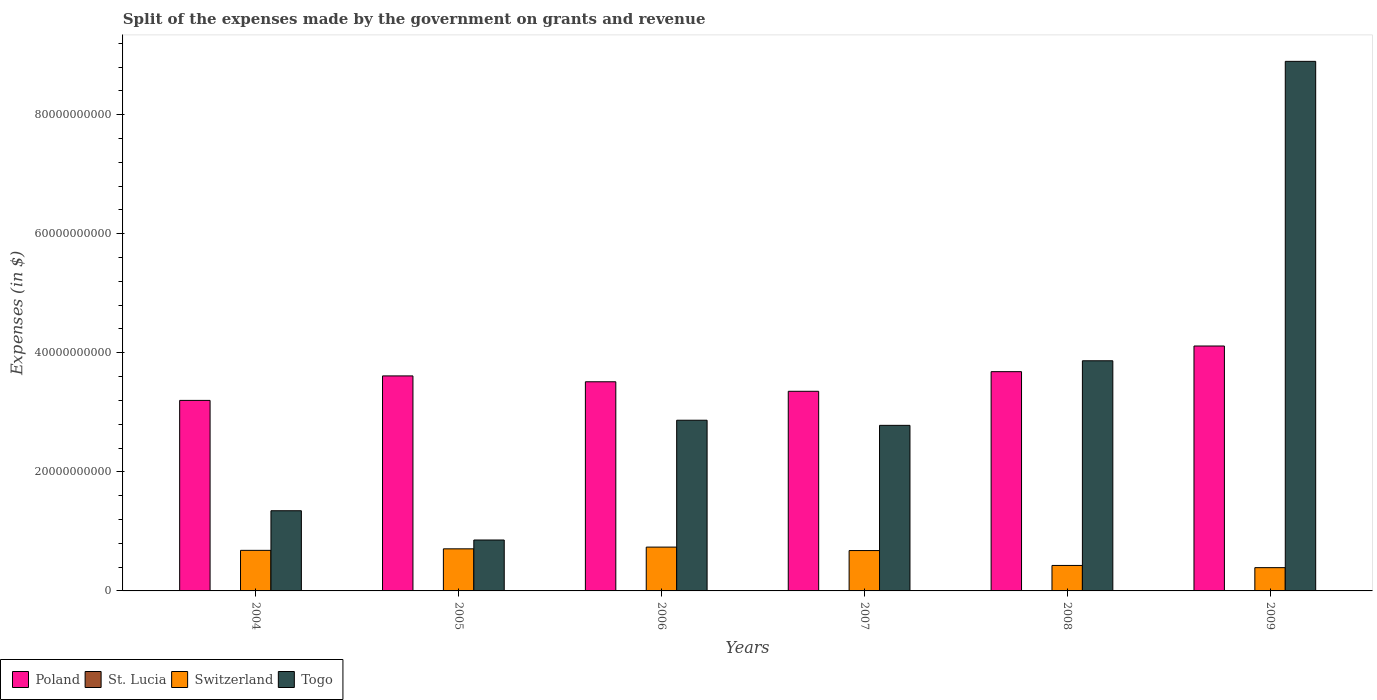How many different coloured bars are there?
Provide a short and direct response. 4. How many groups of bars are there?
Make the answer very short. 6. Are the number of bars on each tick of the X-axis equal?
Provide a short and direct response. Yes. What is the label of the 6th group of bars from the left?
Your answer should be very brief. 2009. In how many cases, is the number of bars for a given year not equal to the number of legend labels?
Give a very brief answer. 0. What is the expenses made by the government on grants and revenue in Switzerland in 2008?
Keep it short and to the point. 4.28e+09. Across all years, what is the maximum expenses made by the government on grants and revenue in St. Lucia?
Give a very brief answer. 2.59e+07. Across all years, what is the minimum expenses made by the government on grants and revenue in Switzerland?
Give a very brief answer. 3.91e+09. In which year was the expenses made by the government on grants and revenue in Switzerland minimum?
Provide a short and direct response. 2009. What is the total expenses made by the government on grants and revenue in Switzerland in the graph?
Provide a succinct answer. 3.62e+1. What is the difference between the expenses made by the government on grants and revenue in St. Lucia in 2005 and that in 2008?
Make the answer very short. -1.65e+07. What is the difference between the expenses made by the government on grants and revenue in Togo in 2007 and the expenses made by the government on grants and revenue in St. Lucia in 2008?
Provide a short and direct response. 2.78e+1. What is the average expenses made by the government on grants and revenue in Switzerland per year?
Provide a short and direct response. 6.04e+09. In the year 2009, what is the difference between the expenses made by the government on grants and revenue in St. Lucia and expenses made by the government on grants and revenue in Poland?
Provide a succinct answer. -4.11e+1. In how many years, is the expenses made by the government on grants and revenue in Switzerland greater than 32000000000 $?
Make the answer very short. 0. What is the ratio of the expenses made by the government on grants and revenue in St. Lucia in 2006 to that in 2009?
Make the answer very short. 0.13. What is the difference between the highest and the second highest expenses made by the government on grants and revenue in Togo?
Ensure brevity in your answer.  5.03e+1. What is the difference between the highest and the lowest expenses made by the government on grants and revenue in Poland?
Your response must be concise. 9.14e+09. Is it the case that in every year, the sum of the expenses made by the government on grants and revenue in Switzerland and expenses made by the government on grants and revenue in Poland is greater than the sum of expenses made by the government on grants and revenue in St. Lucia and expenses made by the government on grants and revenue in Togo?
Provide a short and direct response. No. What does the 2nd bar from the right in 2004 represents?
Your answer should be very brief. Switzerland. Is it the case that in every year, the sum of the expenses made by the government on grants and revenue in Poland and expenses made by the government on grants and revenue in St. Lucia is greater than the expenses made by the government on grants and revenue in Togo?
Offer a terse response. No. How many bars are there?
Keep it short and to the point. 24. Are all the bars in the graph horizontal?
Make the answer very short. No. How many years are there in the graph?
Make the answer very short. 6. Are the values on the major ticks of Y-axis written in scientific E-notation?
Give a very brief answer. No. Where does the legend appear in the graph?
Your answer should be compact. Bottom left. How many legend labels are there?
Offer a very short reply. 4. What is the title of the graph?
Offer a very short reply. Split of the expenses made by the government on grants and revenue. Does "Zimbabwe" appear as one of the legend labels in the graph?
Give a very brief answer. No. What is the label or title of the Y-axis?
Keep it short and to the point. Expenses (in $). What is the Expenses (in $) in Poland in 2004?
Provide a short and direct response. 3.20e+1. What is the Expenses (in $) in Switzerland in 2004?
Provide a succinct answer. 6.81e+09. What is the Expenses (in $) of Togo in 2004?
Give a very brief answer. 1.35e+1. What is the Expenses (in $) of Poland in 2005?
Your response must be concise. 3.61e+1. What is the Expenses (in $) in St. Lucia in 2005?
Give a very brief answer. 4.20e+06. What is the Expenses (in $) of Switzerland in 2005?
Offer a terse response. 7.07e+09. What is the Expenses (in $) of Togo in 2005?
Keep it short and to the point. 8.55e+09. What is the Expenses (in $) of Poland in 2006?
Your answer should be very brief. 3.51e+1. What is the Expenses (in $) in St. Lucia in 2006?
Give a very brief answer. 3.30e+06. What is the Expenses (in $) of Switzerland in 2006?
Give a very brief answer. 7.36e+09. What is the Expenses (in $) of Togo in 2006?
Offer a terse response. 2.87e+1. What is the Expenses (in $) of Poland in 2007?
Make the answer very short. 3.35e+1. What is the Expenses (in $) in St. Lucia in 2007?
Offer a very short reply. 9.30e+06. What is the Expenses (in $) of Switzerland in 2007?
Provide a succinct answer. 6.78e+09. What is the Expenses (in $) of Togo in 2007?
Keep it short and to the point. 2.78e+1. What is the Expenses (in $) of Poland in 2008?
Offer a very short reply. 3.68e+1. What is the Expenses (in $) of St. Lucia in 2008?
Make the answer very short. 2.07e+07. What is the Expenses (in $) of Switzerland in 2008?
Your answer should be compact. 4.28e+09. What is the Expenses (in $) in Togo in 2008?
Your answer should be compact. 3.87e+1. What is the Expenses (in $) of Poland in 2009?
Your response must be concise. 4.11e+1. What is the Expenses (in $) of St. Lucia in 2009?
Provide a succinct answer. 2.59e+07. What is the Expenses (in $) of Switzerland in 2009?
Make the answer very short. 3.91e+09. What is the Expenses (in $) of Togo in 2009?
Your answer should be very brief. 8.90e+1. Across all years, what is the maximum Expenses (in $) in Poland?
Provide a succinct answer. 4.11e+1. Across all years, what is the maximum Expenses (in $) in St. Lucia?
Ensure brevity in your answer.  2.59e+07. Across all years, what is the maximum Expenses (in $) in Switzerland?
Provide a short and direct response. 7.36e+09. Across all years, what is the maximum Expenses (in $) of Togo?
Give a very brief answer. 8.90e+1. Across all years, what is the minimum Expenses (in $) in Poland?
Keep it short and to the point. 3.20e+1. Across all years, what is the minimum Expenses (in $) of St. Lucia?
Make the answer very short. 3.30e+06. Across all years, what is the minimum Expenses (in $) of Switzerland?
Provide a short and direct response. 3.91e+09. Across all years, what is the minimum Expenses (in $) of Togo?
Ensure brevity in your answer.  8.55e+09. What is the total Expenses (in $) of Poland in the graph?
Your answer should be very brief. 2.15e+11. What is the total Expenses (in $) of St. Lucia in the graph?
Your answer should be very brief. 6.94e+07. What is the total Expenses (in $) in Switzerland in the graph?
Give a very brief answer. 3.62e+1. What is the total Expenses (in $) of Togo in the graph?
Provide a succinct answer. 2.06e+11. What is the difference between the Expenses (in $) in Poland in 2004 and that in 2005?
Provide a short and direct response. -4.12e+09. What is the difference between the Expenses (in $) in St. Lucia in 2004 and that in 2005?
Provide a succinct answer. 1.80e+06. What is the difference between the Expenses (in $) in Switzerland in 2004 and that in 2005?
Provide a short and direct response. -2.56e+08. What is the difference between the Expenses (in $) of Togo in 2004 and that in 2005?
Make the answer very short. 4.92e+09. What is the difference between the Expenses (in $) in Poland in 2004 and that in 2006?
Provide a succinct answer. -3.13e+09. What is the difference between the Expenses (in $) in St. Lucia in 2004 and that in 2006?
Ensure brevity in your answer.  2.70e+06. What is the difference between the Expenses (in $) in Switzerland in 2004 and that in 2006?
Your answer should be compact. -5.47e+08. What is the difference between the Expenses (in $) in Togo in 2004 and that in 2006?
Make the answer very short. -1.52e+1. What is the difference between the Expenses (in $) in Poland in 2004 and that in 2007?
Your answer should be very brief. -1.53e+09. What is the difference between the Expenses (in $) in St. Lucia in 2004 and that in 2007?
Make the answer very short. -3.30e+06. What is the difference between the Expenses (in $) of Switzerland in 2004 and that in 2007?
Your answer should be very brief. 3.30e+07. What is the difference between the Expenses (in $) in Togo in 2004 and that in 2007?
Your answer should be very brief. -1.43e+1. What is the difference between the Expenses (in $) in Poland in 2004 and that in 2008?
Provide a succinct answer. -4.83e+09. What is the difference between the Expenses (in $) in St. Lucia in 2004 and that in 2008?
Ensure brevity in your answer.  -1.47e+07. What is the difference between the Expenses (in $) of Switzerland in 2004 and that in 2008?
Keep it short and to the point. 2.54e+09. What is the difference between the Expenses (in $) of Togo in 2004 and that in 2008?
Make the answer very short. -2.52e+1. What is the difference between the Expenses (in $) of Poland in 2004 and that in 2009?
Ensure brevity in your answer.  -9.14e+09. What is the difference between the Expenses (in $) of St. Lucia in 2004 and that in 2009?
Your answer should be very brief. -1.99e+07. What is the difference between the Expenses (in $) of Switzerland in 2004 and that in 2009?
Provide a succinct answer. 2.90e+09. What is the difference between the Expenses (in $) in Togo in 2004 and that in 2009?
Offer a terse response. -7.55e+1. What is the difference between the Expenses (in $) of Poland in 2005 and that in 2006?
Offer a very short reply. 9.86e+08. What is the difference between the Expenses (in $) in Switzerland in 2005 and that in 2006?
Provide a succinct answer. -2.92e+08. What is the difference between the Expenses (in $) of Togo in 2005 and that in 2006?
Provide a short and direct response. -2.01e+1. What is the difference between the Expenses (in $) in Poland in 2005 and that in 2007?
Keep it short and to the point. 2.58e+09. What is the difference between the Expenses (in $) in St. Lucia in 2005 and that in 2007?
Your answer should be compact. -5.10e+06. What is the difference between the Expenses (in $) in Switzerland in 2005 and that in 2007?
Keep it short and to the point. 2.89e+08. What is the difference between the Expenses (in $) in Togo in 2005 and that in 2007?
Give a very brief answer. -1.93e+1. What is the difference between the Expenses (in $) in Poland in 2005 and that in 2008?
Give a very brief answer. -7.14e+08. What is the difference between the Expenses (in $) of St. Lucia in 2005 and that in 2008?
Give a very brief answer. -1.65e+07. What is the difference between the Expenses (in $) of Switzerland in 2005 and that in 2008?
Your answer should be very brief. 2.79e+09. What is the difference between the Expenses (in $) in Togo in 2005 and that in 2008?
Provide a succinct answer. -3.01e+1. What is the difference between the Expenses (in $) in Poland in 2005 and that in 2009?
Give a very brief answer. -5.02e+09. What is the difference between the Expenses (in $) of St. Lucia in 2005 and that in 2009?
Provide a succinct answer. -2.17e+07. What is the difference between the Expenses (in $) in Switzerland in 2005 and that in 2009?
Ensure brevity in your answer.  3.16e+09. What is the difference between the Expenses (in $) of Togo in 2005 and that in 2009?
Ensure brevity in your answer.  -8.04e+1. What is the difference between the Expenses (in $) of Poland in 2006 and that in 2007?
Your answer should be very brief. 1.60e+09. What is the difference between the Expenses (in $) in St. Lucia in 2006 and that in 2007?
Offer a very short reply. -6.00e+06. What is the difference between the Expenses (in $) in Switzerland in 2006 and that in 2007?
Make the answer very short. 5.80e+08. What is the difference between the Expenses (in $) in Togo in 2006 and that in 2007?
Provide a short and direct response. 8.62e+08. What is the difference between the Expenses (in $) in Poland in 2006 and that in 2008?
Provide a short and direct response. -1.70e+09. What is the difference between the Expenses (in $) in St. Lucia in 2006 and that in 2008?
Offer a very short reply. -1.74e+07. What is the difference between the Expenses (in $) of Switzerland in 2006 and that in 2008?
Provide a short and direct response. 3.08e+09. What is the difference between the Expenses (in $) in Togo in 2006 and that in 2008?
Your answer should be very brief. -9.99e+09. What is the difference between the Expenses (in $) of Poland in 2006 and that in 2009?
Offer a very short reply. -6.01e+09. What is the difference between the Expenses (in $) of St. Lucia in 2006 and that in 2009?
Give a very brief answer. -2.26e+07. What is the difference between the Expenses (in $) in Switzerland in 2006 and that in 2009?
Keep it short and to the point. 3.45e+09. What is the difference between the Expenses (in $) in Togo in 2006 and that in 2009?
Provide a succinct answer. -6.03e+1. What is the difference between the Expenses (in $) in Poland in 2007 and that in 2008?
Provide a succinct answer. -3.30e+09. What is the difference between the Expenses (in $) of St. Lucia in 2007 and that in 2008?
Provide a succinct answer. -1.14e+07. What is the difference between the Expenses (in $) in Switzerland in 2007 and that in 2008?
Your answer should be very brief. 2.50e+09. What is the difference between the Expenses (in $) in Togo in 2007 and that in 2008?
Ensure brevity in your answer.  -1.08e+1. What is the difference between the Expenses (in $) in Poland in 2007 and that in 2009?
Make the answer very short. -7.61e+09. What is the difference between the Expenses (in $) of St. Lucia in 2007 and that in 2009?
Offer a terse response. -1.66e+07. What is the difference between the Expenses (in $) of Switzerland in 2007 and that in 2009?
Your answer should be very brief. 2.87e+09. What is the difference between the Expenses (in $) of Togo in 2007 and that in 2009?
Offer a very short reply. -6.11e+1. What is the difference between the Expenses (in $) of Poland in 2008 and that in 2009?
Offer a very short reply. -4.31e+09. What is the difference between the Expenses (in $) of St. Lucia in 2008 and that in 2009?
Offer a very short reply. -5.20e+06. What is the difference between the Expenses (in $) in Switzerland in 2008 and that in 2009?
Give a very brief answer. 3.68e+08. What is the difference between the Expenses (in $) in Togo in 2008 and that in 2009?
Offer a terse response. -5.03e+1. What is the difference between the Expenses (in $) of Poland in 2004 and the Expenses (in $) of St. Lucia in 2005?
Your answer should be compact. 3.20e+1. What is the difference between the Expenses (in $) of Poland in 2004 and the Expenses (in $) of Switzerland in 2005?
Provide a succinct answer. 2.49e+1. What is the difference between the Expenses (in $) of Poland in 2004 and the Expenses (in $) of Togo in 2005?
Give a very brief answer. 2.34e+1. What is the difference between the Expenses (in $) in St. Lucia in 2004 and the Expenses (in $) in Switzerland in 2005?
Your answer should be compact. -7.06e+09. What is the difference between the Expenses (in $) of St. Lucia in 2004 and the Expenses (in $) of Togo in 2005?
Keep it short and to the point. -8.55e+09. What is the difference between the Expenses (in $) in Switzerland in 2004 and the Expenses (in $) in Togo in 2005?
Make the answer very short. -1.74e+09. What is the difference between the Expenses (in $) of Poland in 2004 and the Expenses (in $) of St. Lucia in 2006?
Keep it short and to the point. 3.20e+1. What is the difference between the Expenses (in $) of Poland in 2004 and the Expenses (in $) of Switzerland in 2006?
Your answer should be very brief. 2.46e+1. What is the difference between the Expenses (in $) of Poland in 2004 and the Expenses (in $) of Togo in 2006?
Offer a terse response. 3.33e+09. What is the difference between the Expenses (in $) in St. Lucia in 2004 and the Expenses (in $) in Switzerland in 2006?
Your answer should be very brief. -7.36e+09. What is the difference between the Expenses (in $) of St. Lucia in 2004 and the Expenses (in $) of Togo in 2006?
Your answer should be compact. -2.87e+1. What is the difference between the Expenses (in $) in Switzerland in 2004 and the Expenses (in $) in Togo in 2006?
Give a very brief answer. -2.19e+1. What is the difference between the Expenses (in $) of Poland in 2004 and the Expenses (in $) of St. Lucia in 2007?
Your answer should be very brief. 3.20e+1. What is the difference between the Expenses (in $) in Poland in 2004 and the Expenses (in $) in Switzerland in 2007?
Offer a very short reply. 2.52e+1. What is the difference between the Expenses (in $) in Poland in 2004 and the Expenses (in $) in Togo in 2007?
Keep it short and to the point. 4.19e+09. What is the difference between the Expenses (in $) of St. Lucia in 2004 and the Expenses (in $) of Switzerland in 2007?
Your answer should be very brief. -6.77e+09. What is the difference between the Expenses (in $) in St. Lucia in 2004 and the Expenses (in $) in Togo in 2007?
Ensure brevity in your answer.  -2.78e+1. What is the difference between the Expenses (in $) of Switzerland in 2004 and the Expenses (in $) of Togo in 2007?
Give a very brief answer. -2.10e+1. What is the difference between the Expenses (in $) of Poland in 2004 and the Expenses (in $) of St. Lucia in 2008?
Ensure brevity in your answer.  3.20e+1. What is the difference between the Expenses (in $) of Poland in 2004 and the Expenses (in $) of Switzerland in 2008?
Provide a succinct answer. 2.77e+1. What is the difference between the Expenses (in $) of Poland in 2004 and the Expenses (in $) of Togo in 2008?
Offer a very short reply. -6.66e+09. What is the difference between the Expenses (in $) in St. Lucia in 2004 and the Expenses (in $) in Switzerland in 2008?
Your answer should be very brief. -4.27e+09. What is the difference between the Expenses (in $) in St. Lucia in 2004 and the Expenses (in $) in Togo in 2008?
Your answer should be compact. -3.87e+1. What is the difference between the Expenses (in $) in Switzerland in 2004 and the Expenses (in $) in Togo in 2008?
Your answer should be very brief. -3.18e+1. What is the difference between the Expenses (in $) in Poland in 2004 and the Expenses (in $) in St. Lucia in 2009?
Ensure brevity in your answer.  3.20e+1. What is the difference between the Expenses (in $) in Poland in 2004 and the Expenses (in $) in Switzerland in 2009?
Make the answer very short. 2.81e+1. What is the difference between the Expenses (in $) in Poland in 2004 and the Expenses (in $) in Togo in 2009?
Your answer should be compact. -5.70e+1. What is the difference between the Expenses (in $) in St. Lucia in 2004 and the Expenses (in $) in Switzerland in 2009?
Ensure brevity in your answer.  -3.90e+09. What is the difference between the Expenses (in $) of St. Lucia in 2004 and the Expenses (in $) of Togo in 2009?
Ensure brevity in your answer.  -8.89e+1. What is the difference between the Expenses (in $) of Switzerland in 2004 and the Expenses (in $) of Togo in 2009?
Your response must be concise. -8.21e+1. What is the difference between the Expenses (in $) of Poland in 2005 and the Expenses (in $) of St. Lucia in 2006?
Offer a terse response. 3.61e+1. What is the difference between the Expenses (in $) in Poland in 2005 and the Expenses (in $) in Switzerland in 2006?
Offer a terse response. 2.88e+1. What is the difference between the Expenses (in $) in Poland in 2005 and the Expenses (in $) in Togo in 2006?
Your answer should be compact. 7.44e+09. What is the difference between the Expenses (in $) of St. Lucia in 2005 and the Expenses (in $) of Switzerland in 2006?
Provide a short and direct response. -7.36e+09. What is the difference between the Expenses (in $) of St. Lucia in 2005 and the Expenses (in $) of Togo in 2006?
Your answer should be very brief. -2.87e+1. What is the difference between the Expenses (in $) of Switzerland in 2005 and the Expenses (in $) of Togo in 2006?
Your response must be concise. -2.16e+1. What is the difference between the Expenses (in $) in Poland in 2005 and the Expenses (in $) in St. Lucia in 2007?
Provide a short and direct response. 3.61e+1. What is the difference between the Expenses (in $) in Poland in 2005 and the Expenses (in $) in Switzerland in 2007?
Provide a succinct answer. 2.93e+1. What is the difference between the Expenses (in $) of Poland in 2005 and the Expenses (in $) of Togo in 2007?
Make the answer very short. 8.31e+09. What is the difference between the Expenses (in $) in St. Lucia in 2005 and the Expenses (in $) in Switzerland in 2007?
Provide a succinct answer. -6.78e+09. What is the difference between the Expenses (in $) of St. Lucia in 2005 and the Expenses (in $) of Togo in 2007?
Ensure brevity in your answer.  -2.78e+1. What is the difference between the Expenses (in $) of Switzerland in 2005 and the Expenses (in $) of Togo in 2007?
Your response must be concise. -2.07e+1. What is the difference between the Expenses (in $) of Poland in 2005 and the Expenses (in $) of St. Lucia in 2008?
Your response must be concise. 3.61e+1. What is the difference between the Expenses (in $) in Poland in 2005 and the Expenses (in $) in Switzerland in 2008?
Offer a terse response. 3.18e+1. What is the difference between the Expenses (in $) of Poland in 2005 and the Expenses (in $) of Togo in 2008?
Keep it short and to the point. -2.54e+09. What is the difference between the Expenses (in $) in St. Lucia in 2005 and the Expenses (in $) in Switzerland in 2008?
Your answer should be compact. -4.27e+09. What is the difference between the Expenses (in $) in St. Lucia in 2005 and the Expenses (in $) in Togo in 2008?
Your answer should be compact. -3.87e+1. What is the difference between the Expenses (in $) in Switzerland in 2005 and the Expenses (in $) in Togo in 2008?
Your answer should be very brief. -3.16e+1. What is the difference between the Expenses (in $) in Poland in 2005 and the Expenses (in $) in St. Lucia in 2009?
Give a very brief answer. 3.61e+1. What is the difference between the Expenses (in $) of Poland in 2005 and the Expenses (in $) of Switzerland in 2009?
Give a very brief answer. 3.22e+1. What is the difference between the Expenses (in $) of Poland in 2005 and the Expenses (in $) of Togo in 2009?
Give a very brief answer. -5.28e+1. What is the difference between the Expenses (in $) in St. Lucia in 2005 and the Expenses (in $) in Switzerland in 2009?
Give a very brief answer. -3.91e+09. What is the difference between the Expenses (in $) of St. Lucia in 2005 and the Expenses (in $) of Togo in 2009?
Keep it short and to the point. -8.89e+1. What is the difference between the Expenses (in $) in Switzerland in 2005 and the Expenses (in $) in Togo in 2009?
Offer a terse response. -8.19e+1. What is the difference between the Expenses (in $) of Poland in 2006 and the Expenses (in $) of St. Lucia in 2007?
Your answer should be compact. 3.51e+1. What is the difference between the Expenses (in $) in Poland in 2006 and the Expenses (in $) in Switzerland in 2007?
Offer a very short reply. 2.83e+1. What is the difference between the Expenses (in $) in Poland in 2006 and the Expenses (in $) in Togo in 2007?
Keep it short and to the point. 7.32e+09. What is the difference between the Expenses (in $) in St. Lucia in 2006 and the Expenses (in $) in Switzerland in 2007?
Give a very brief answer. -6.78e+09. What is the difference between the Expenses (in $) of St. Lucia in 2006 and the Expenses (in $) of Togo in 2007?
Provide a succinct answer. -2.78e+1. What is the difference between the Expenses (in $) in Switzerland in 2006 and the Expenses (in $) in Togo in 2007?
Your answer should be compact. -2.04e+1. What is the difference between the Expenses (in $) in Poland in 2006 and the Expenses (in $) in St. Lucia in 2008?
Offer a terse response. 3.51e+1. What is the difference between the Expenses (in $) in Poland in 2006 and the Expenses (in $) in Switzerland in 2008?
Your answer should be very brief. 3.09e+1. What is the difference between the Expenses (in $) of Poland in 2006 and the Expenses (in $) of Togo in 2008?
Your answer should be very brief. -3.53e+09. What is the difference between the Expenses (in $) of St. Lucia in 2006 and the Expenses (in $) of Switzerland in 2008?
Make the answer very short. -4.27e+09. What is the difference between the Expenses (in $) of St. Lucia in 2006 and the Expenses (in $) of Togo in 2008?
Offer a terse response. -3.87e+1. What is the difference between the Expenses (in $) of Switzerland in 2006 and the Expenses (in $) of Togo in 2008?
Offer a very short reply. -3.13e+1. What is the difference between the Expenses (in $) in Poland in 2006 and the Expenses (in $) in St. Lucia in 2009?
Give a very brief answer. 3.51e+1. What is the difference between the Expenses (in $) in Poland in 2006 and the Expenses (in $) in Switzerland in 2009?
Make the answer very short. 3.12e+1. What is the difference between the Expenses (in $) of Poland in 2006 and the Expenses (in $) of Togo in 2009?
Make the answer very short. -5.38e+1. What is the difference between the Expenses (in $) of St. Lucia in 2006 and the Expenses (in $) of Switzerland in 2009?
Your answer should be compact. -3.91e+09. What is the difference between the Expenses (in $) in St. Lucia in 2006 and the Expenses (in $) in Togo in 2009?
Make the answer very short. -8.89e+1. What is the difference between the Expenses (in $) of Switzerland in 2006 and the Expenses (in $) of Togo in 2009?
Provide a short and direct response. -8.16e+1. What is the difference between the Expenses (in $) of Poland in 2007 and the Expenses (in $) of St. Lucia in 2008?
Provide a short and direct response. 3.35e+1. What is the difference between the Expenses (in $) in Poland in 2007 and the Expenses (in $) in Switzerland in 2008?
Offer a very short reply. 2.93e+1. What is the difference between the Expenses (in $) in Poland in 2007 and the Expenses (in $) in Togo in 2008?
Keep it short and to the point. -5.13e+09. What is the difference between the Expenses (in $) in St. Lucia in 2007 and the Expenses (in $) in Switzerland in 2008?
Make the answer very short. -4.27e+09. What is the difference between the Expenses (in $) in St. Lucia in 2007 and the Expenses (in $) in Togo in 2008?
Provide a short and direct response. -3.86e+1. What is the difference between the Expenses (in $) of Switzerland in 2007 and the Expenses (in $) of Togo in 2008?
Your answer should be very brief. -3.19e+1. What is the difference between the Expenses (in $) of Poland in 2007 and the Expenses (in $) of St. Lucia in 2009?
Keep it short and to the point. 3.35e+1. What is the difference between the Expenses (in $) of Poland in 2007 and the Expenses (in $) of Switzerland in 2009?
Provide a succinct answer. 2.96e+1. What is the difference between the Expenses (in $) of Poland in 2007 and the Expenses (in $) of Togo in 2009?
Give a very brief answer. -5.54e+1. What is the difference between the Expenses (in $) of St. Lucia in 2007 and the Expenses (in $) of Switzerland in 2009?
Your answer should be very brief. -3.90e+09. What is the difference between the Expenses (in $) of St. Lucia in 2007 and the Expenses (in $) of Togo in 2009?
Ensure brevity in your answer.  -8.89e+1. What is the difference between the Expenses (in $) in Switzerland in 2007 and the Expenses (in $) in Togo in 2009?
Provide a short and direct response. -8.22e+1. What is the difference between the Expenses (in $) of Poland in 2008 and the Expenses (in $) of St. Lucia in 2009?
Your response must be concise. 3.68e+1. What is the difference between the Expenses (in $) in Poland in 2008 and the Expenses (in $) in Switzerland in 2009?
Ensure brevity in your answer.  3.29e+1. What is the difference between the Expenses (in $) of Poland in 2008 and the Expenses (in $) of Togo in 2009?
Keep it short and to the point. -5.21e+1. What is the difference between the Expenses (in $) of St. Lucia in 2008 and the Expenses (in $) of Switzerland in 2009?
Your answer should be compact. -3.89e+09. What is the difference between the Expenses (in $) of St. Lucia in 2008 and the Expenses (in $) of Togo in 2009?
Give a very brief answer. -8.89e+1. What is the difference between the Expenses (in $) of Switzerland in 2008 and the Expenses (in $) of Togo in 2009?
Your answer should be compact. -8.47e+1. What is the average Expenses (in $) in Poland per year?
Ensure brevity in your answer.  3.58e+1. What is the average Expenses (in $) in St. Lucia per year?
Your response must be concise. 1.16e+07. What is the average Expenses (in $) of Switzerland per year?
Your answer should be compact. 6.04e+09. What is the average Expenses (in $) in Togo per year?
Your answer should be compact. 3.44e+1. In the year 2004, what is the difference between the Expenses (in $) in Poland and Expenses (in $) in St. Lucia?
Give a very brief answer. 3.20e+1. In the year 2004, what is the difference between the Expenses (in $) of Poland and Expenses (in $) of Switzerland?
Keep it short and to the point. 2.52e+1. In the year 2004, what is the difference between the Expenses (in $) in Poland and Expenses (in $) in Togo?
Offer a terse response. 1.85e+1. In the year 2004, what is the difference between the Expenses (in $) of St. Lucia and Expenses (in $) of Switzerland?
Provide a succinct answer. -6.81e+09. In the year 2004, what is the difference between the Expenses (in $) of St. Lucia and Expenses (in $) of Togo?
Ensure brevity in your answer.  -1.35e+1. In the year 2004, what is the difference between the Expenses (in $) in Switzerland and Expenses (in $) in Togo?
Provide a short and direct response. -6.66e+09. In the year 2005, what is the difference between the Expenses (in $) of Poland and Expenses (in $) of St. Lucia?
Your answer should be very brief. 3.61e+1. In the year 2005, what is the difference between the Expenses (in $) of Poland and Expenses (in $) of Switzerland?
Your answer should be very brief. 2.90e+1. In the year 2005, what is the difference between the Expenses (in $) in Poland and Expenses (in $) in Togo?
Make the answer very short. 2.76e+1. In the year 2005, what is the difference between the Expenses (in $) in St. Lucia and Expenses (in $) in Switzerland?
Provide a succinct answer. -7.07e+09. In the year 2005, what is the difference between the Expenses (in $) of St. Lucia and Expenses (in $) of Togo?
Give a very brief answer. -8.55e+09. In the year 2005, what is the difference between the Expenses (in $) of Switzerland and Expenses (in $) of Togo?
Ensure brevity in your answer.  -1.48e+09. In the year 2006, what is the difference between the Expenses (in $) in Poland and Expenses (in $) in St. Lucia?
Offer a very short reply. 3.51e+1. In the year 2006, what is the difference between the Expenses (in $) of Poland and Expenses (in $) of Switzerland?
Ensure brevity in your answer.  2.78e+1. In the year 2006, what is the difference between the Expenses (in $) in Poland and Expenses (in $) in Togo?
Your answer should be very brief. 6.46e+09. In the year 2006, what is the difference between the Expenses (in $) of St. Lucia and Expenses (in $) of Switzerland?
Give a very brief answer. -7.36e+09. In the year 2006, what is the difference between the Expenses (in $) of St. Lucia and Expenses (in $) of Togo?
Make the answer very short. -2.87e+1. In the year 2006, what is the difference between the Expenses (in $) of Switzerland and Expenses (in $) of Togo?
Offer a terse response. -2.13e+1. In the year 2007, what is the difference between the Expenses (in $) of Poland and Expenses (in $) of St. Lucia?
Your answer should be compact. 3.35e+1. In the year 2007, what is the difference between the Expenses (in $) of Poland and Expenses (in $) of Switzerland?
Keep it short and to the point. 2.68e+1. In the year 2007, what is the difference between the Expenses (in $) of Poland and Expenses (in $) of Togo?
Keep it short and to the point. 5.72e+09. In the year 2007, what is the difference between the Expenses (in $) in St. Lucia and Expenses (in $) in Switzerland?
Your response must be concise. -6.77e+09. In the year 2007, what is the difference between the Expenses (in $) in St. Lucia and Expenses (in $) in Togo?
Make the answer very short. -2.78e+1. In the year 2007, what is the difference between the Expenses (in $) of Switzerland and Expenses (in $) of Togo?
Ensure brevity in your answer.  -2.10e+1. In the year 2008, what is the difference between the Expenses (in $) of Poland and Expenses (in $) of St. Lucia?
Make the answer very short. 3.68e+1. In the year 2008, what is the difference between the Expenses (in $) of Poland and Expenses (in $) of Switzerland?
Ensure brevity in your answer.  3.26e+1. In the year 2008, what is the difference between the Expenses (in $) of Poland and Expenses (in $) of Togo?
Ensure brevity in your answer.  -1.83e+09. In the year 2008, what is the difference between the Expenses (in $) of St. Lucia and Expenses (in $) of Switzerland?
Your answer should be compact. -4.26e+09. In the year 2008, what is the difference between the Expenses (in $) of St. Lucia and Expenses (in $) of Togo?
Offer a very short reply. -3.86e+1. In the year 2008, what is the difference between the Expenses (in $) of Switzerland and Expenses (in $) of Togo?
Provide a succinct answer. -3.44e+1. In the year 2009, what is the difference between the Expenses (in $) in Poland and Expenses (in $) in St. Lucia?
Offer a very short reply. 4.11e+1. In the year 2009, what is the difference between the Expenses (in $) in Poland and Expenses (in $) in Switzerland?
Offer a terse response. 3.72e+1. In the year 2009, what is the difference between the Expenses (in $) of Poland and Expenses (in $) of Togo?
Make the answer very short. -4.78e+1. In the year 2009, what is the difference between the Expenses (in $) of St. Lucia and Expenses (in $) of Switzerland?
Make the answer very short. -3.88e+09. In the year 2009, what is the difference between the Expenses (in $) in St. Lucia and Expenses (in $) in Togo?
Give a very brief answer. -8.89e+1. In the year 2009, what is the difference between the Expenses (in $) of Switzerland and Expenses (in $) of Togo?
Keep it short and to the point. -8.50e+1. What is the ratio of the Expenses (in $) in Poland in 2004 to that in 2005?
Make the answer very short. 0.89. What is the ratio of the Expenses (in $) of St. Lucia in 2004 to that in 2005?
Your response must be concise. 1.43. What is the ratio of the Expenses (in $) in Switzerland in 2004 to that in 2005?
Provide a succinct answer. 0.96. What is the ratio of the Expenses (in $) of Togo in 2004 to that in 2005?
Give a very brief answer. 1.58. What is the ratio of the Expenses (in $) in Poland in 2004 to that in 2006?
Make the answer very short. 0.91. What is the ratio of the Expenses (in $) in St. Lucia in 2004 to that in 2006?
Offer a terse response. 1.82. What is the ratio of the Expenses (in $) in Switzerland in 2004 to that in 2006?
Keep it short and to the point. 0.93. What is the ratio of the Expenses (in $) of Togo in 2004 to that in 2006?
Your response must be concise. 0.47. What is the ratio of the Expenses (in $) in Poland in 2004 to that in 2007?
Your answer should be compact. 0.95. What is the ratio of the Expenses (in $) in St. Lucia in 2004 to that in 2007?
Keep it short and to the point. 0.65. What is the ratio of the Expenses (in $) in Togo in 2004 to that in 2007?
Offer a terse response. 0.48. What is the ratio of the Expenses (in $) in Poland in 2004 to that in 2008?
Offer a very short reply. 0.87. What is the ratio of the Expenses (in $) in St. Lucia in 2004 to that in 2008?
Offer a very short reply. 0.29. What is the ratio of the Expenses (in $) of Switzerland in 2004 to that in 2008?
Provide a succinct answer. 1.59. What is the ratio of the Expenses (in $) in Togo in 2004 to that in 2008?
Offer a very short reply. 0.35. What is the ratio of the Expenses (in $) of Poland in 2004 to that in 2009?
Your answer should be very brief. 0.78. What is the ratio of the Expenses (in $) of St. Lucia in 2004 to that in 2009?
Ensure brevity in your answer.  0.23. What is the ratio of the Expenses (in $) in Switzerland in 2004 to that in 2009?
Your answer should be compact. 1.74. What is the ratio of the Expenses (in $) of Togo in 2004 to that in 2009?
Provide a succinct answer. 0.15. What is the ratio of the Expenses (in $) in Poland in 2005 to that in 2006?
Offer a terse response. 1.03. What is the ratio of the Expenses (in $) of St. Lucia in 2005 to that in 2006?
Keep it short and to the point. 1.27. What is the ratio of the Expenses (in $) in Switzerland in 2005 to that in 2006?
Offer a terse response. 0.96. What is the ratio of the Expenses (in $) of Togo in 2005 to that in 2006?
Your answer should be compact. 0.3. What is the ratio of the Expenses (in $) of Poland in 2005 to that in 2007?
Keep it short and to the point. 1.08. What is the ratio of the Expenses (in $) in St. Lucia in 2005 to that in 2007?
Keep it short and to the point. 0.45. What is the ratio of the Expenses (in $) of Switzerland in 2005 to that in 2007?
Your response must be concise. 1.04. What is the ratio of the Expenses (in $) in Togo in 2005 to that in 2007?
Your answer should be very brief. 0.31. What is the ratio of the Expenses (in $) in Poland in 2005 to that in 2008?
Offer a very short reply. 0.98. What is the ratio of the Expenses (in $) of St. Lucia in 2005 to that in 2008?
Make the answer very short. 0.2. What is the ratio of the Expenses (in $) in Switzerland in 2005 to that in 2008?
Your response must be concise. 1.65. What is the ratio of the Expenses (in $) in Togo in 2005 to that in 2008?
Provide a short and direct response. 0.22. What is the ratio of the Expenses (in $) in Poland in 2005 to that in 2009?
Your answer should be compact. 0.88. What is the ratio of the Expenses (in $) in St. Lucia in 2005 to that in 2009?
Keep it short and to the point. 0.16. What is the ratio of the Expenses (in $) of Switzerland in 2005 to that in 2009?
Provide a short and direct response. 1.81. What is the ratio of the Expenses (in $) in Togo in 2005 to that in 2009?
Your answer should be very brief. 0.1. What is the ratio of the Expenses (in $) of Poland in 2006 to that in 2007?
Ensure brevity in your answer.  1.05. What is the ratio of the Expenses (in $) in St. Lucia in 2006 to that in 2007?
Give a very brief answer. 0.35. What is the ratio of the Expenses (in $) in Switzerland in 2006 to that in 2007?
Your answer should be compact. 1.09. What is the ratio of the Expenses (in $) in Togo in 2006 to that in 2007?
Your answer should be very brief. 1.03. What is the ratio of the Expenses (in $) in Poland in 2006 to that in 2008?
Give a very brief answer. 0.95. What is the ratio of the Expenses (in $) of St. Lucia in 2006 to that in 2008?
Provide a short and direct response. 0.16. What is the ratio of the Expenses (in $) of Switzerland in 2006 to that in 2008?
Ensure brevity in your answer.  1.72. What is the ratio of the Expenses (in $) of Togo in 2006 to that in 2008?
Your answer should be very brief. 0.74. What is the ratio of the Expenses (in $) in Poland in 2006 to that in 2009?
Your answer should be compact. 0.85. What is the ratio of the Expenses (in $) in St. Lucia in 2006 to that in 2009?
Keep it short and to the point. 0.13. What is the ratio of the Expenses (in $) in Switzerland in 2006 to that in 2009?
Provide a succinct answer. 1.88. What is the ratio of the Expenses (in $) of Togo in 2006 to that in 2009?
Your response must be concise. 0.32. What is the ratio of the Expenses (in $) in Poland in 2007 to that in 2008?
Offer a terse response. 0.91. What is the ratio of the Expenses (in $) in St. Lucia in 2007 to that in 2008?
Provide a short and direct response. 0.45. What is the ratio of the Expenses (in $) in Switzerland in 2007 to that in 2008?
Offer a terse response. 1.58. What is the ratio of the Expenses (in $) in Togo in 2007 to that in 2008?
Offer a very short reply. 0.72. What is the ratio of the Expenses (in $) in Poland in 2007 to that in 2009?
Provide a short and direct response. 0.82. What is the ratio of the Expenses (in $) of St. Lucia in 2007 to that in 2009?
Your answer should be compact. 0.36. What is the ratio of the Expenses (in $) of Switzerland in 2007 to that in 2009?
Provide a short and direct response. 1.73. What is the ratio of the Expenses (in $) of Togo in 2007 to that in 2009?
Your answer should be compact. 0.31. What is the ratio of the Expenses (in $) of Poland in 2008 to that in 2009?
Provide a succinct answer. 0.9. What is the ratio of the Expenses (in $) of St. Lucia in 2008 to that in 2009?
Your answer should be compact. 0.8. What is the ratio of the Expenses (in $) of Switzerland in 2008 to that in 2009?
Give a very brief answer. 1.09. What is the ratio of the Expenses (in $) in Togo in 2008 to that in 2009?
Your answer should be very brief. 0.43. What is the difference between the highest and the second highest Expenses (in $) of Poland?
Keep it short and to the point. 4.31e+09. What is the difference between the highest and the second highest Expenses (in $) of St. Lucia?
Ensure brevity in your answer.  5.20e+06. What is the difference between the highest and the second highest Expenses (in $) of Switzerland?
Keep it short and to the point. 2.92e+08. What is the difference between the highest and the second highest Expenses (in $) of Togo?
Your answer should be compact. 5.03e+1. What is the difference between the highest and the lowest Expenses (in $) of Poland?
Offer a very short reply. 9.14e+09. What is the difference between the highest and the lowest Expenses (in $) of St. Lucia?
Offer a very short reply. 2.26e+07. What is the difference between the highest and the lowest Expenses (in $) in Switzerland?
Your response must be concise. 3.45e+09. What is the difference between the highest and the lowest Expenses (in $) in Togo?
Provide a short and direct response. 8.04e+1. 